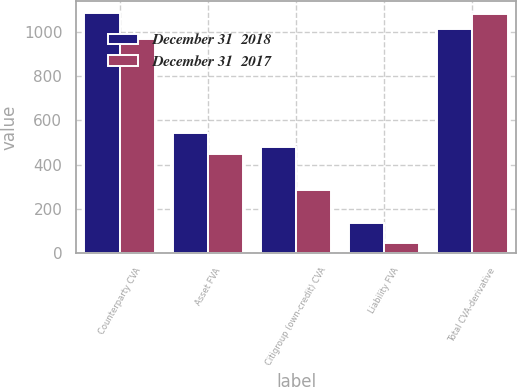<chart> <loc_0><loc_0><loc_500><loc_500><stacked_bar_chart><ecel><fcel>Counterparty CVA<fcel>Asset FVA<fcel>Citigroup (own-credit) CVA<fcel>Liability FVA<fcel>Total CVA-derivative<nl><fcel>December 31  2018<fcel>1085<fcel>544<fcel>482<fcel>135<fcel>1012<nl><fcel>December 31  2017<fcel>970<fcel>447<fcel>287<fcel>47<fcel>1083<nl></chart> 